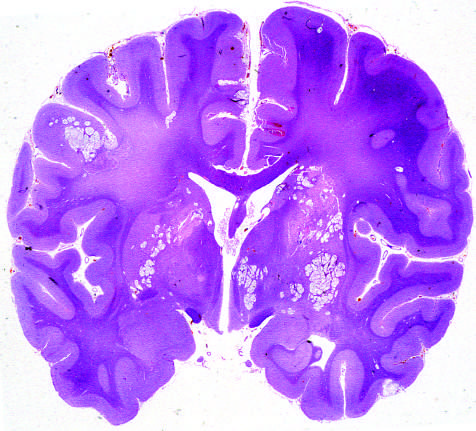what is associated with the spread of organisms in the perivascular spaces?
Answer the question using a single word or phrase. Numerous areas tissue destruction 